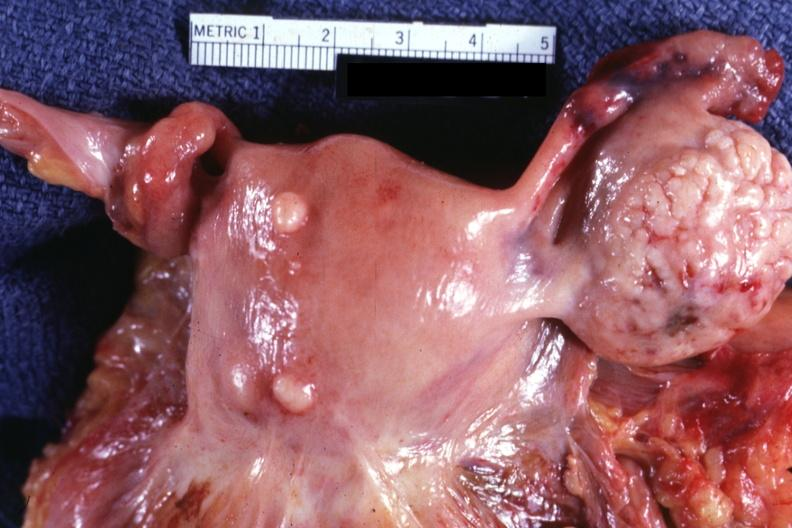what is present?
Answer the question using a single word or phrase. Female reproductive 